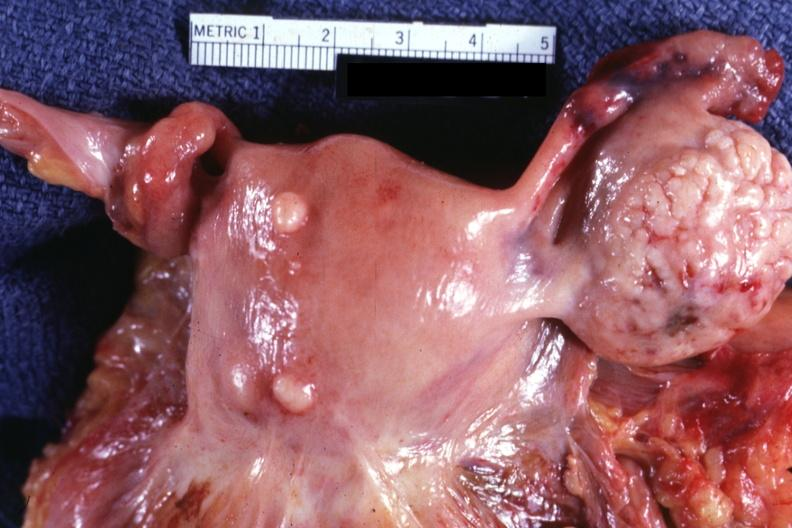what is present?
Answer the question using a single word or phrase. Female reproductive 